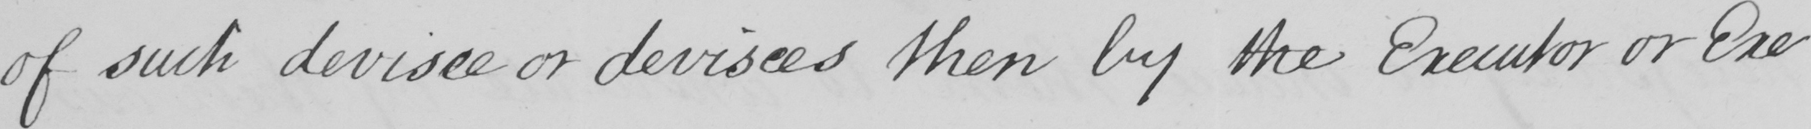Please provide the text content of this handwritten line. of such devisee or devisees then by the Executor or Exe- 